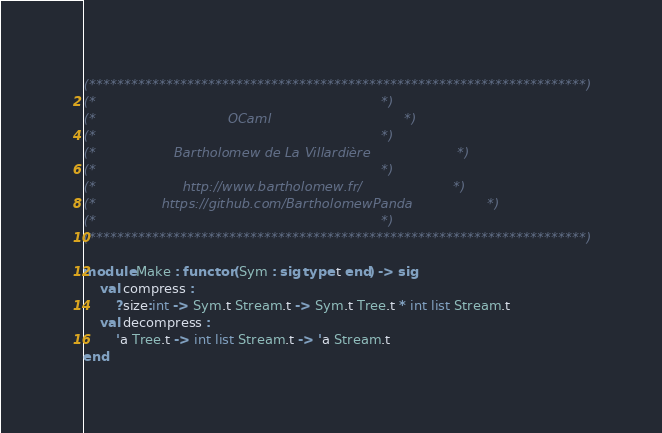<code> <loc_0><loc_0><loc_500><loc_500><_OCaml_>(***********************************************************************)
(*                                                                     *)
(*                                OCaml                                *)
(*                                                                     *)
(*                   Bartholomew de La Villardière                     *)
(*                                                                     *)
(*                     http://www.bartholomew.fr/                      *)
(*                https://github.com/BartholomewPanda                  *)
(*                                                                     *)
(***********************************************************************)

module Make : functor (Sym : sig type t end) -> sig
    val compress :
        ?size:int -> Sym.t Stream.t -> Sym.t Tree.t * int list Stream.t
    val decompress :
        'a Tree.t -> int list Stream.t -> 'a Stream.t
end

</code> 